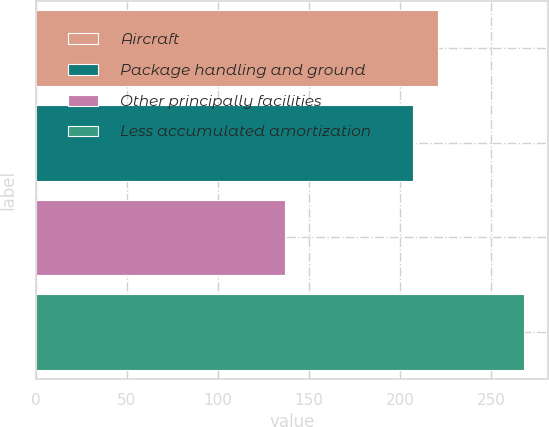Convert chart. <chart><loc_0><loc_0><loc_500><loc_500><bar_chart><fcel>Aircraft<fcel>Package handling and ground<fcel>Other principally facilities<fcel>Less accumulated amortization<nl><fcel>221<fcel>207<fcel>137<fcel>268<nl></chart> 